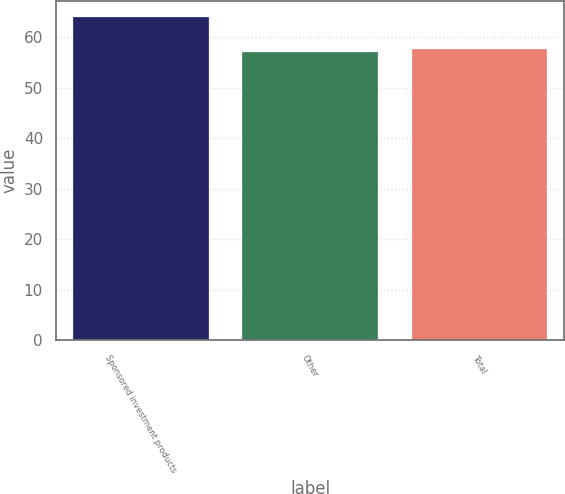<chart> <loc_0><loc_0><loc_500><loc_500><bar_chart><fcel>Sponsored investment products<fcel>Other<fcel>Total<nl><fcel>64<fcel>57<fcel>57.7<nl></chart> 